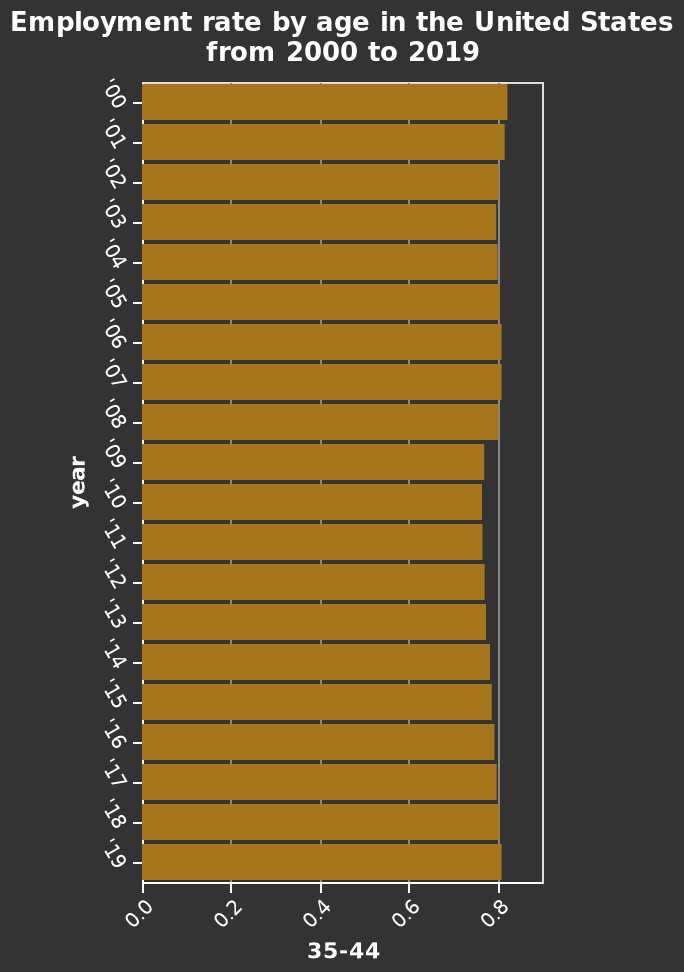<image>
Offer a thorough analysis of the image. Employment rate dropped slightly from 09 to 06. Although the bar chart is not clear as to by how much. What is the title of the bar plot? The title of the bar plot is "Employment rate by age in the United States from 2000 to 2019." What is the variable represented on the x-axis? The x-axis represents the age category "35-44." What is the time period covered by the bar plot? The time period covered by the bar plot is from 2000 to 2019. Is the title of the bar plot "Employment rate by age in the United States from 2000 to 2020"? No.The title of the bar plot is "Employment rate by age in the United States from 2000 to 2019." 